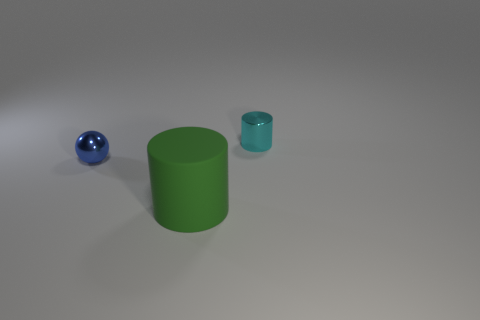Is there any other thing that is made of the same material as the big green cylinder?
Give a very brief answer. No. There is a thing that is in front of the object to the left of the cylinder that is in front of the blue object; what size is it?
Provide a succinct answer. Large. What number of small things have the same material as the tiny blue sphere?
Make the answer very short. 1. Is the number of small objects less than the number of cyan things?
Your answer should be compact. No. The matte thing that is the same shape as the small cyan metallic thing is what size?
Provide a succinct answer. Large. Is the material of the tiny thing in front of the small cyan metallic cylinder the same as the green cylinder?
Your answer should be very brief. No. Is the big green matte object the same shape as the blue object?
Offer a terse response. No. How many objects are either metal things that are to the left of the small cyan shiny cylinder or large objects?
Offer a very short reply. 2. The cyan thing that is made of the same material as the tiny blue object is what size?
Make the answer very short. Small. How many large objects are either blue things or red cylinders?
Offer a terse response. 0. 